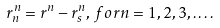Convert formula to latex. <formula><loc_0><loc_0><loc_500><loc_500>r _ { n } ^ { n } = r ^ { n } - r _ { s } ^ { n } , \, f o r n = 1 , 2 , 3 , \dots .</formula> 